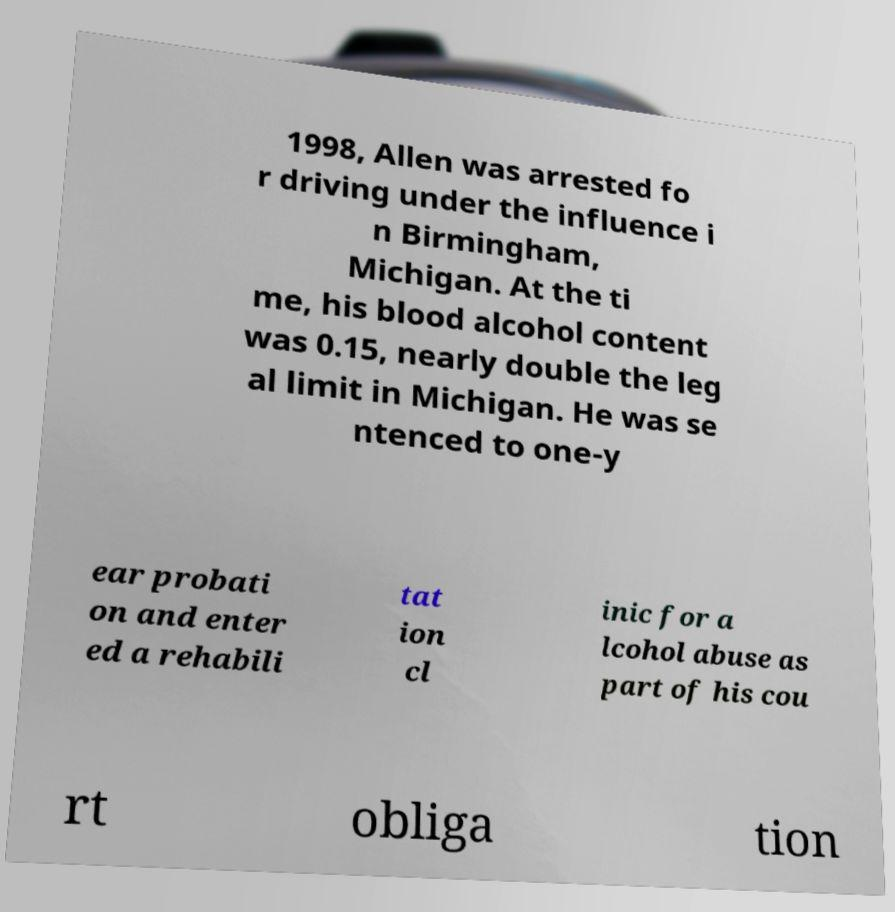What messages or text are displayed in this image? I need them in a readable, typed format. 1998, Allen was arrested fo r driving under the influence i n Birmingham, Michigan. At the ti me, his blood alcohol content was 0.15, nearly double the leg al limit in Michigan. He was se ntenced to one-y ear probati on and enter ed a rehabili tat ion cl inic for a lcohol abuse as part of his cou rt obliga tion 